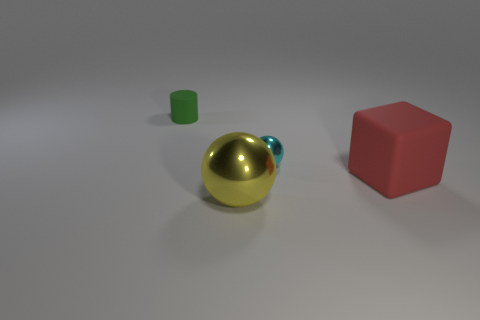Add 3 small purple spheres. How many objects exist? 7 Subtract all cubes. How many objects are left? 3 Add 2 red rubber blocks. How many red rubber blocks are left? 3 Add 4 small blue metal cylinders. How many small blue metal cylinders exist? 4 Subtract 0 gray balls. How many objects are left? 4 Subtract all big purple matte objects. Subtract all small green rubber cylinders. How many objects are left? 3 